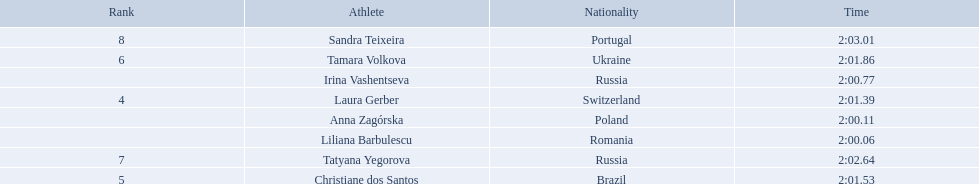What athletes are in the top five for the women's 800 metres? Liliana Barbulescu, Anna Zagórska, Irina Vashentseva, Laura Gerber, Christiane dos Santos. Which athletes are in the top 3? Liliana Barbulescu, Anna Zagórska, Irina Vashentseva. Who is the second place runner in the women's 800 metres? Anna Zagórska. What is the second place runner's time? 2:00.11. 